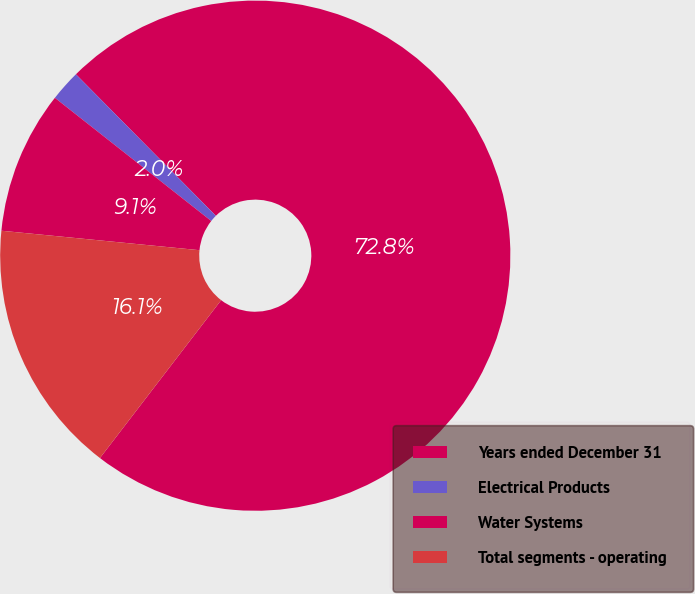Convert chart. <chart><loc_0><loc_0><loc_500><loc_500><pie_chart><fcel>Years ended December 31<fcel>Electrical Products<fcel>Water Systems<fcel>Total segments - operating<nl><fcel>72.83%<fcel>1.97%<fcel>9.06%<fcel>16.14%<nl></chart> 